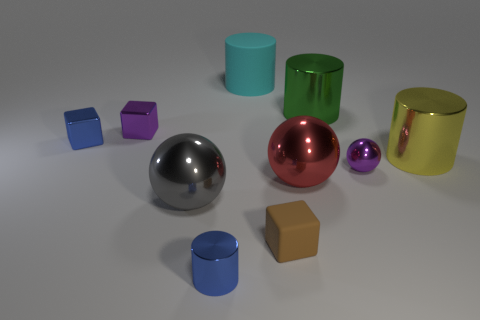Subtract all gray blocks. Subtract all red cylinders. How many blocks are left? 3 Subtract all balls. How many objects are left? 7 Add 2 large yellow metallic objects. How many large yellow metallic objects exist? 3 Subtract 1 brown blocks. How many objects are left? 9 Subtract all blue matte blocks. Subtract all yellow cylinders. How many objects are left? 9 Add 4 tiny purple shiny balls. How many tiny purple shiny balls are left? 5 